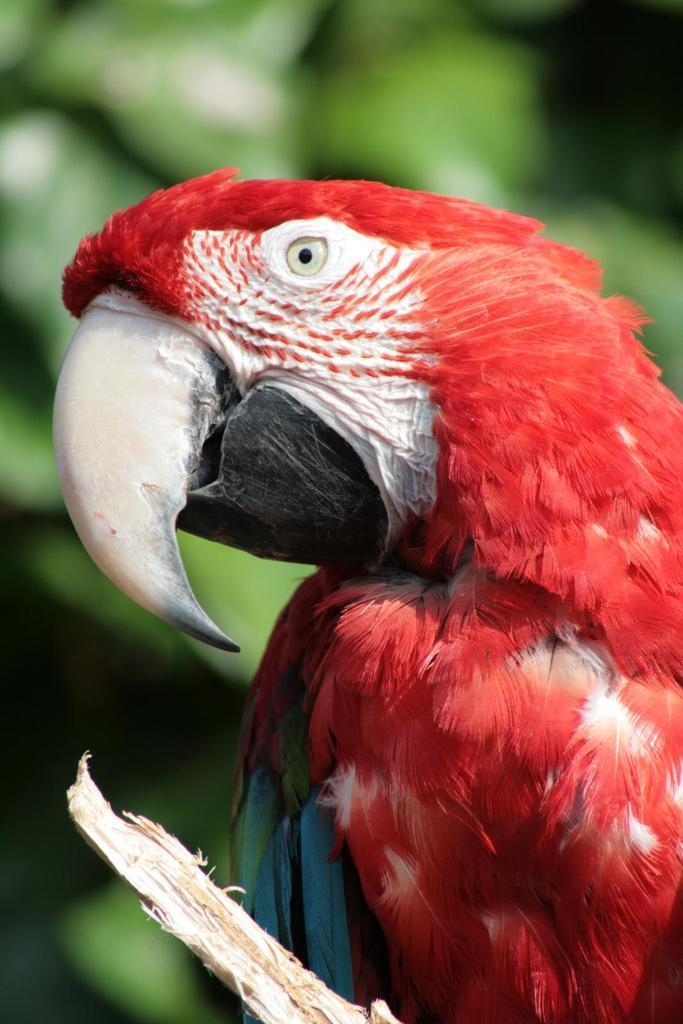Can you describe this image briefly? In this picture I can see there is parrot and it is in red color and it has some blue and green feathers. There is a tree here and in the backdrop I can see there are trees. 